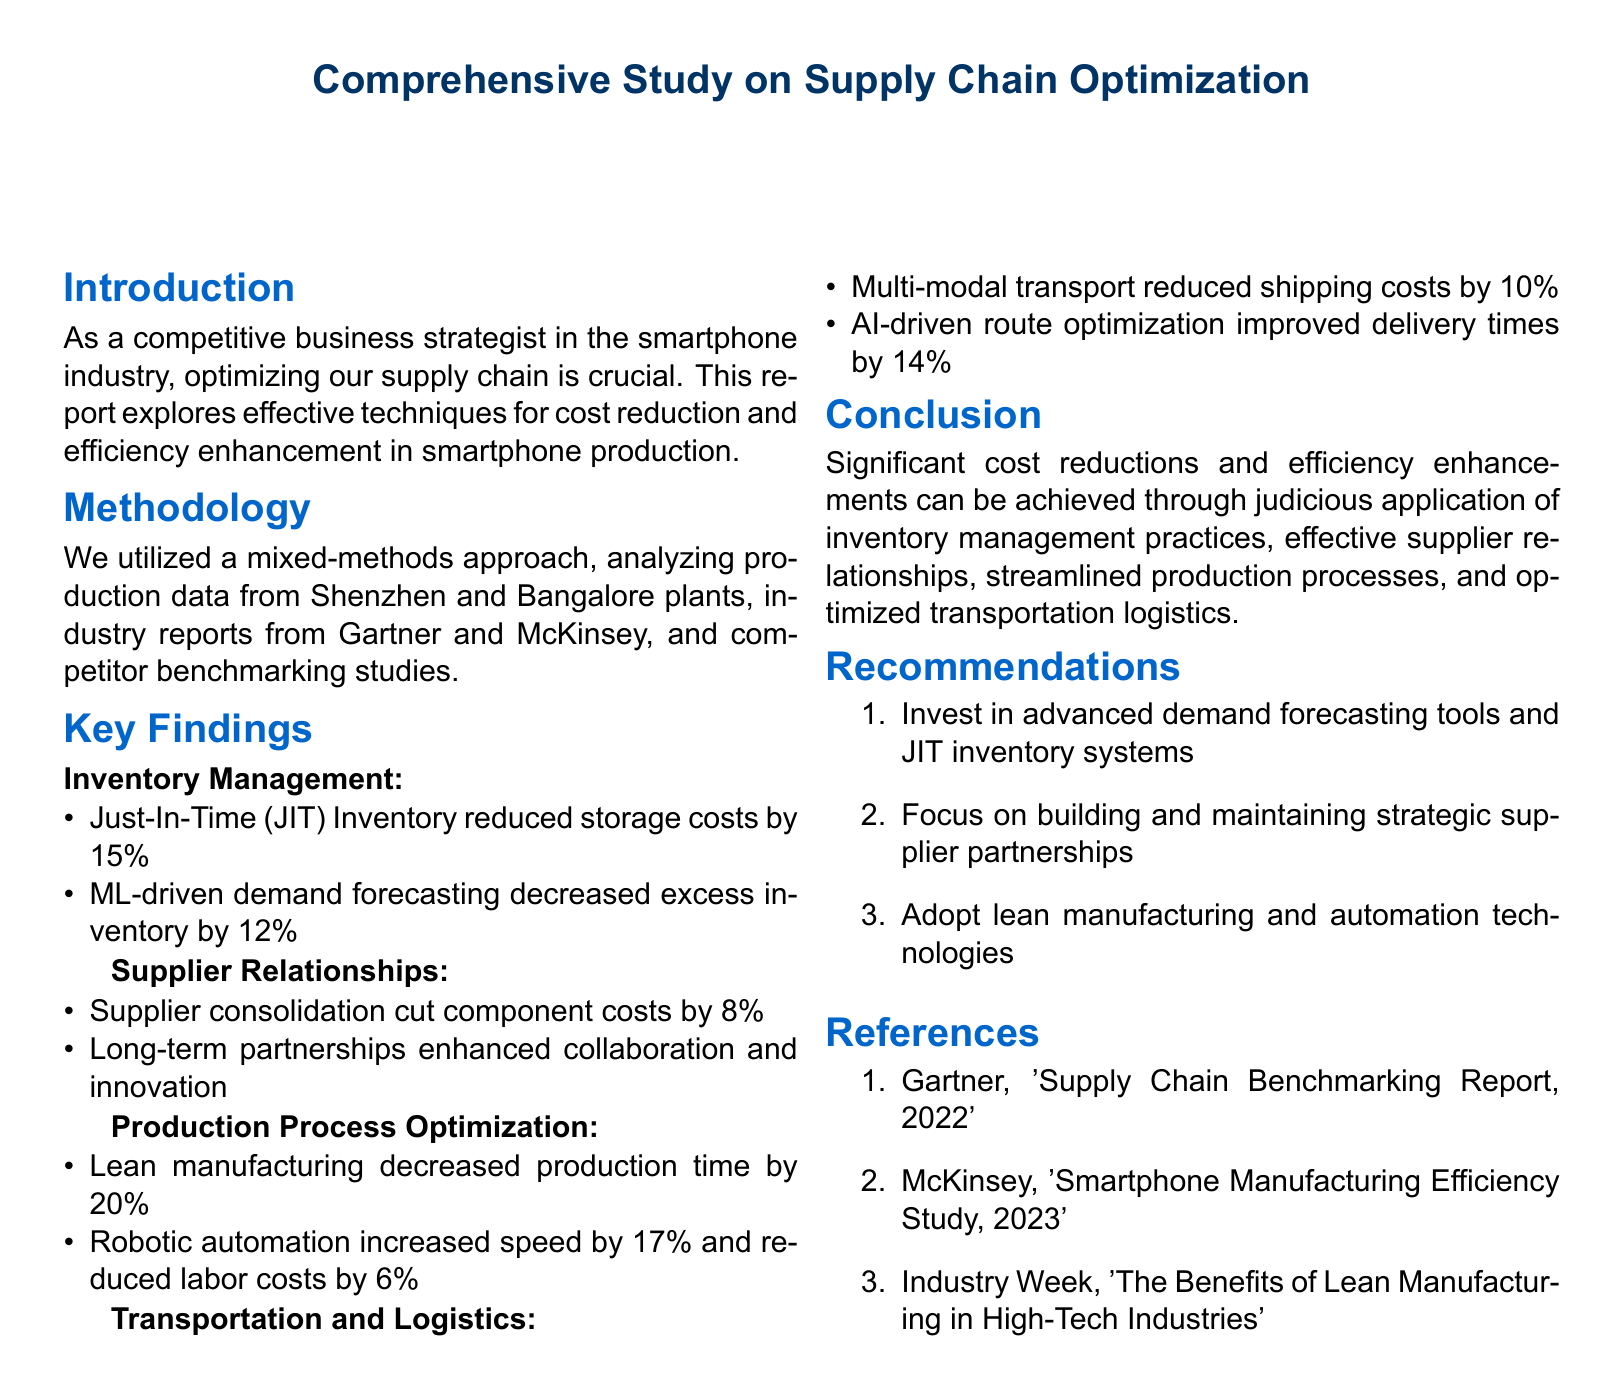What is the cost reduction percentage achieved by Just-In-Time inventory? The report states that Just-In-Time inventory reduced storage costs by 15%.
Answer: 15% What methodology was utilized for the study? The report mentions a mixed-methods approach involving production data analysis, industry reports, and competitor benchmarking.
Answer: Mixed-methods approach What is the decrease in excess inventory attributed to machine learning-driven demand forecasting? The document indicates that ML-driven demand forecasting decreased excess inventory by 12%.
Answer: 12% By what percentage did lean manufacturing decrease production time? The findings show that lean manufacturing decreased production time by 20%.
Answer: 20% What was the cost reduction achieved through supplier consolidation? The report states that supplier consolidation cut component costs by 8%.
Answer: 8% What recommendation is made regarding demand forecasting tools? One of the recommendations specifies investing in advanced demand forecasting tools and JIT inventory systems.
Answer: Advanced demand forecasting tools Which report is referenced regarding supply chain benchmarking? The document references Gartner's 'Supply Chain Benchmarking Report, 2022'.
Answer: Gartner's 'Supply Chain Benchmarking Report, 2022' What year is cited for the McKinsey study on smartphone manufacturing efficiency? The McKinsey study mentioned in the document is from the year 2023.
Answer: 2023 What advanced technology is suggested for improving delivery times? The report recommends using AI-driven route optimization to improve delivery times.
Answer: AI-driven route optimization 